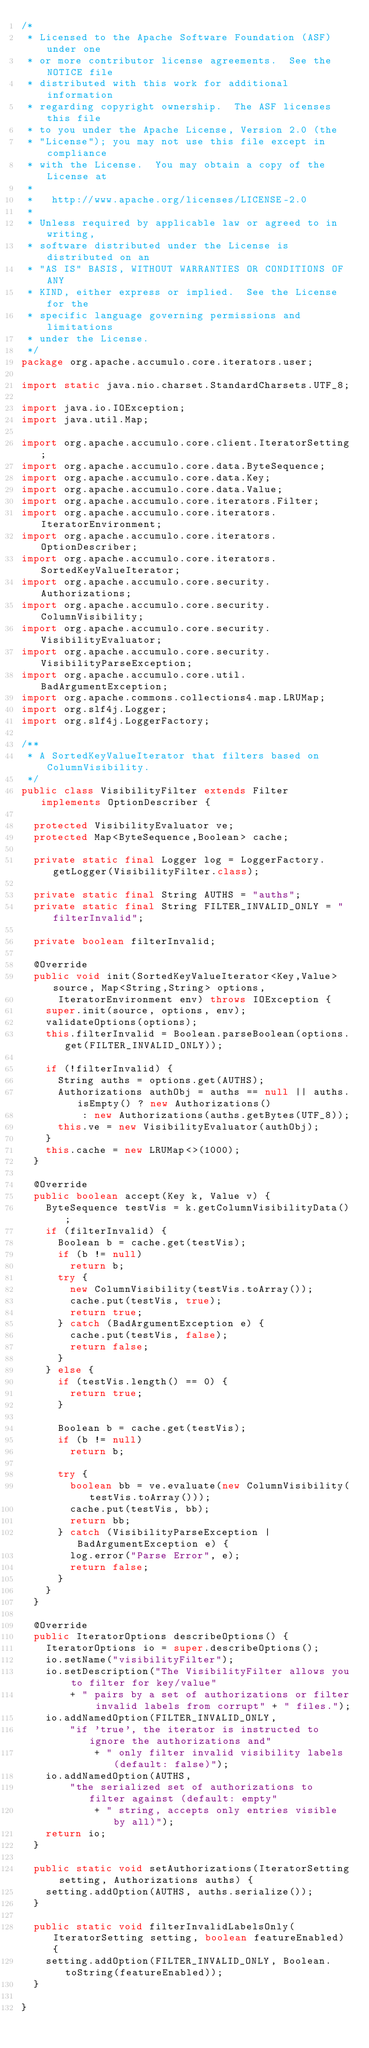<code> <loc_0><loc_0><loc_500><loc_500><_Java_>/*
 * Licensed to the Apache Software Foundation (ASF) under one
 * or more contributor license agreements.  See the NOTICE file
 * distributed with this work for additional information
 * regarding copyright ownership.  The ASF licenses this file
 * to you under the Apache License, Version 2.0 (the
 * "License"); you may not use this file except in compliance
 * with the License.  You may obtain a copy of the License at
 *
 *   http://www.apache.org/licenses/LICENSE-2.0
 *
 * Unless required by applicable law or agreed to in writing,
 * software distributed under the License is distributed on an
 * "AS IS" BASIS, WITHOUT WARRANTIES OR CONDITIONS OF ANY
 * KIND, either express or implied.  See the License for the
 * specific language governing permissions and limitations
 * under the License.
 */
package org.apache.accumulo.core.iterators.user;

import static java.nio.charset.StandardCharsets.UTF_8;

import java.io.IOException;
import java.util.Map;

import org.apache.accumulo.core.client.IteratorSetting;
import org.apache.accumulo.core.data.ByteSequence;
import org.apache.accumulo.core.data.Key;
import org.apache.accumulo.core.data.Value;
import org.apache.accumulo.core.iterators.Filter;
import org.apache.accumulo.core.iterators.IteratorEnvironment;
import org.apache.accumulo.core.iterators.OptionDescriber;
import org.apache.accumulo.core.iterators.SortedKeyValueIterator;
import org.apache.accumulo.core.security.Authorizations;
import org.apache.accumulo.core.security.ColumnVisibility;
import org.apache.accumulo.core.security.VisibilityEvaluator;
import org.apache.accumulo.core.security.VisibilityParseException;
import org.apache.accumulo.core.util.BadArgumentException;
import org.apache.commons.collections4.map.LRUMap;
import org.slf4j.Logger;
import org.slf4j.LoggerFactory;

/**
 * A SortedKeyValueIterator that filters based on ColumnVisibility.
 */
public class VisibilityFilter extends Filter implements OptionDescriber {

  protected VisibilityEvaluator ve;
  protected Map<ByteSequence,Boolean> cache;

  private static final Logger log = LoggerFactory.getLogger(VisibilityFilter.class);

  private static final String AUTHS = "auths";
  private static final String FILTER_INVALID_ONLY = "filterInvalid";

  private boolean filterInvalid;

  @Override
  public void init(SortedKeyValueIterator<Key,Value> source, Map<String,String> options,
      IteratorEnvironment env) throws IOException {
    super.init(source, options, env);
    validateOptions(options);
    this.filterInvalid = Boolean.parseBoolean(options.get(FILTER_INVALID_ONLY));

    if (!filterInvalid) {
      String auths = options.get(AUTHS);
      Authorizations authObj = auths == null || auths.isEmpty() ? new Authorizations()
          : new Authorizations(auths.getBytes(UTF_8));
      this.ve = new VisibilityEvaluator(authObj);
    }
    this.cache = new LRUMap<>(1000);
  }

  @Override
  public boolean accept(Key k, Value v) {
    ByteSequence testVis = k.getColumnVisibilityData();
    if (filterInvalid) {
      Boolean b = cache.get(testVis);
      if (b != null)
        return b;
      try {
        new ColumnVisibility(testVis.toArray());
        cache.put(testVis, true);
        return true;
      } catch (BadArgumentException e) {
        cache.put(testVis, false);
        return false;
      }
    } else {
      if (testVis.length() == 0) {
        return true;
      }

      Boolean b = cache.get(testVis);
      if (b != null)
        return b;

      try {
        boolean bb = ve.evaluate(new ColumnVisibility(testVis.toArray()));
        cache.put(testVis, bb);
        return bb;
      } catch (VisibilityParseException | BadArgumentException e) {
        log.error("Parse Error", e);
        return false;
      }
    }
  }

  @Override
  public IteratorOptions describeOptions() {
    IteratorOptions io = super.describeOptions();
    io.setName("visibilityFilter");
    io.setDescription("The VisibilityFilter allows you to filter for key/value"
        + " pairs by a set of authorizations or filter invalid labels from corrupt" + " files.");
    io.addNamedOption(FILTER_INVALID_ONLY,
        "if 'true', the iterator is instructed to ignore the authorizations and"
            + " only filter invalid visibility labels (default: false)");
    io.addNamedOption(AUTHS,
        "the serialized set of authorizations to filter against (default: empty"
            + " string, accepts only entries visible by all)");
    return io;
  }

  public static void setAuthorizations(IteratorSetting setting, Authorizations auths) {
    setting.addOption(AUTHS, auths.serialize());
  }

  public static void filterInvalidLabelsOnly(IteratorSetting setting, boolean featureEnabled) {
    setting.addOption(FILTER_INVALID_ONLY, Boolean.toString(featureEnabled));
  }

}
</code> 